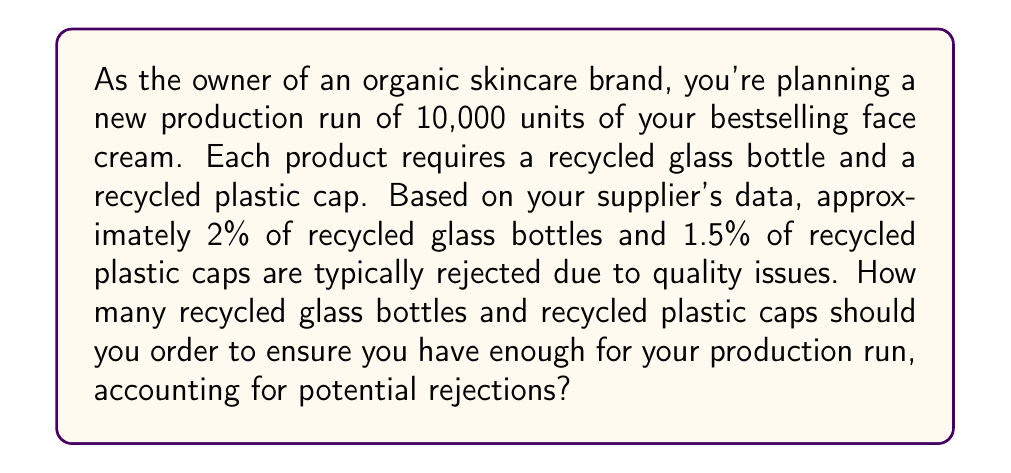What is the answer to this math problem? Let's approach this problem step-by-step:

1. Calculate the number of glass bottles needed:
   - We need 10,000 bottles for the production run.
   - 2% of bottles are expected to be rejected.
   - Let $x$ be the number of bottles to order.
   - The equation: $x - 0.02x = 10,000$
   - Simplifying: $0.98x = 10,000$
   - Solving for $x$: $x = \frac{10,000}{0.98} \approx 10,204.08$

2. Calculate the number of plastic caps needed:
   - We need 10,000 caps for the production run.
   - 1.5% of caps are expected to be rejected.
   - Let $y$ be the number of caps to order.
   - The equation: $y - 0.015y = 10,000$
   - Simplifying: $0.985y = 10,000$
   - Solving for $y$: $y = \frac{10,000}{0.985} \approx 10,152.28$

3. Round up to the nearest whole number:
   - For bottles: $\lceil 10,204.08 \rceil = 10,205$
   - For caps: $\lceil 10,152.28 \rceil = 10,153$

Therefore, you should order 10,205 recycled glass bottles and 10,153 recycled plastic caps to ensure you have enough for your production run, accounting for potential rejections.
Answer: Order 10,205 recycled glass bottles and 10,153 recycled plastic caps. 